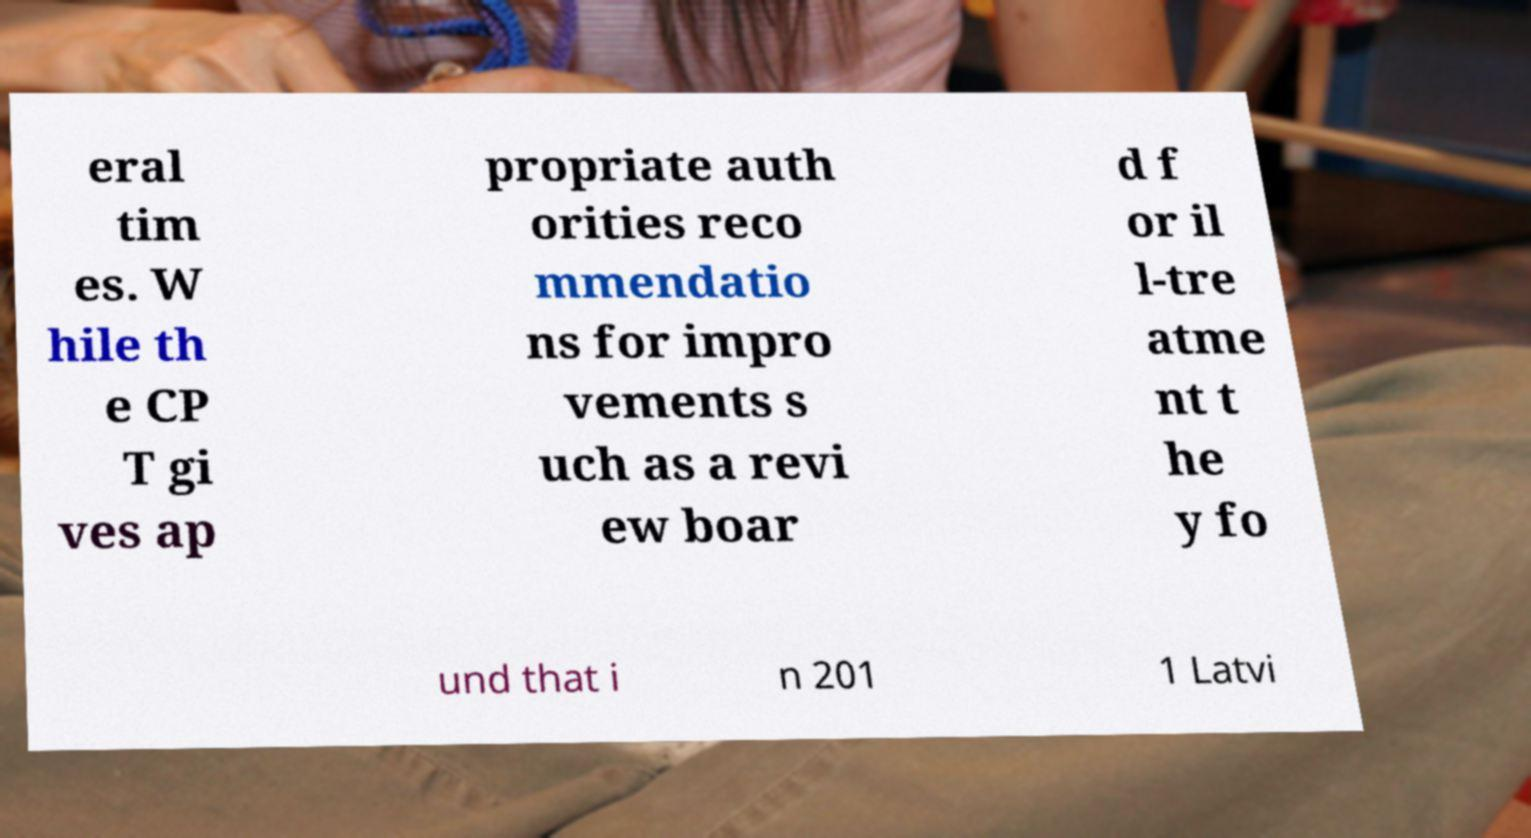For documentation purposes, I need the text within this image transcribed. Could you provide that? eral tim es. W hile th e CP T gi ves ap propriate auth orities reco mmendatio ns for impro vements s uch as a revi ew boar d f or il l-tre atme nt t he y fo und that i n 201 1 Latvi 